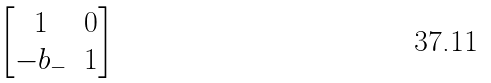Convert formula to latex. <formula><loc_0><loc_0><loc_500><loc_500>\begin{bmatrix} 1 & 0 \\ - b _ { - } & 1 \end{bmatrix}</formula> 